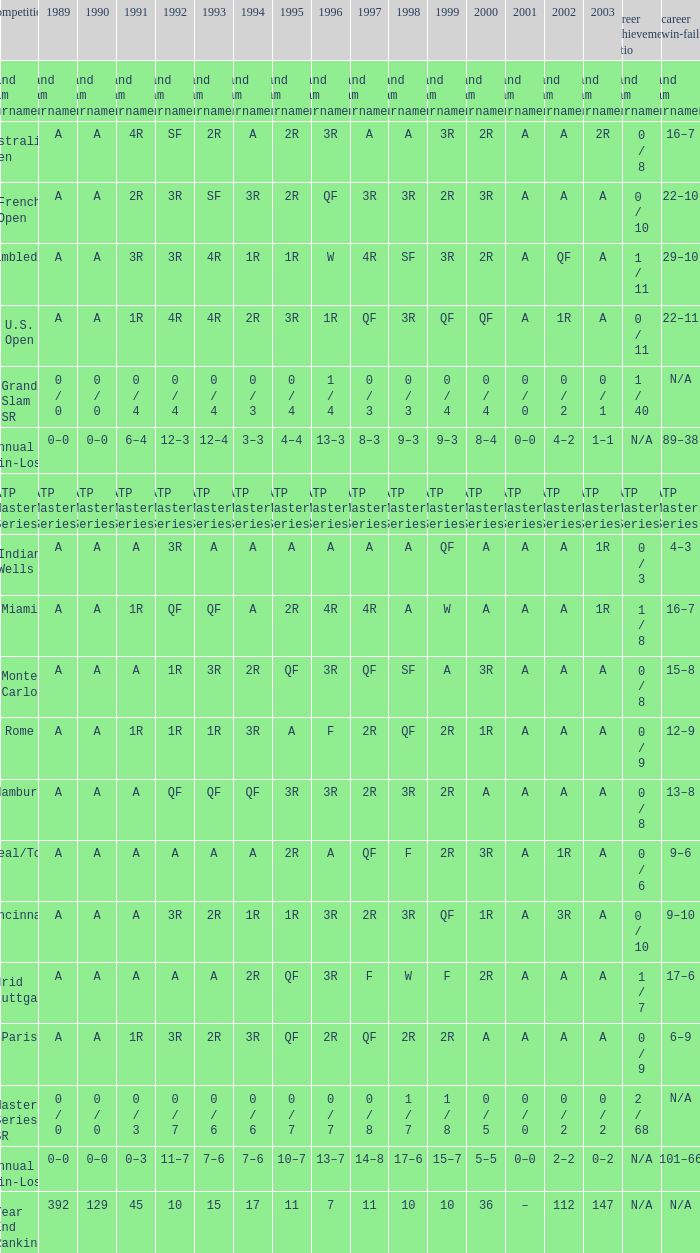What was the value in 1995 for A in 2000 at the Indian Wells tournament? A. 